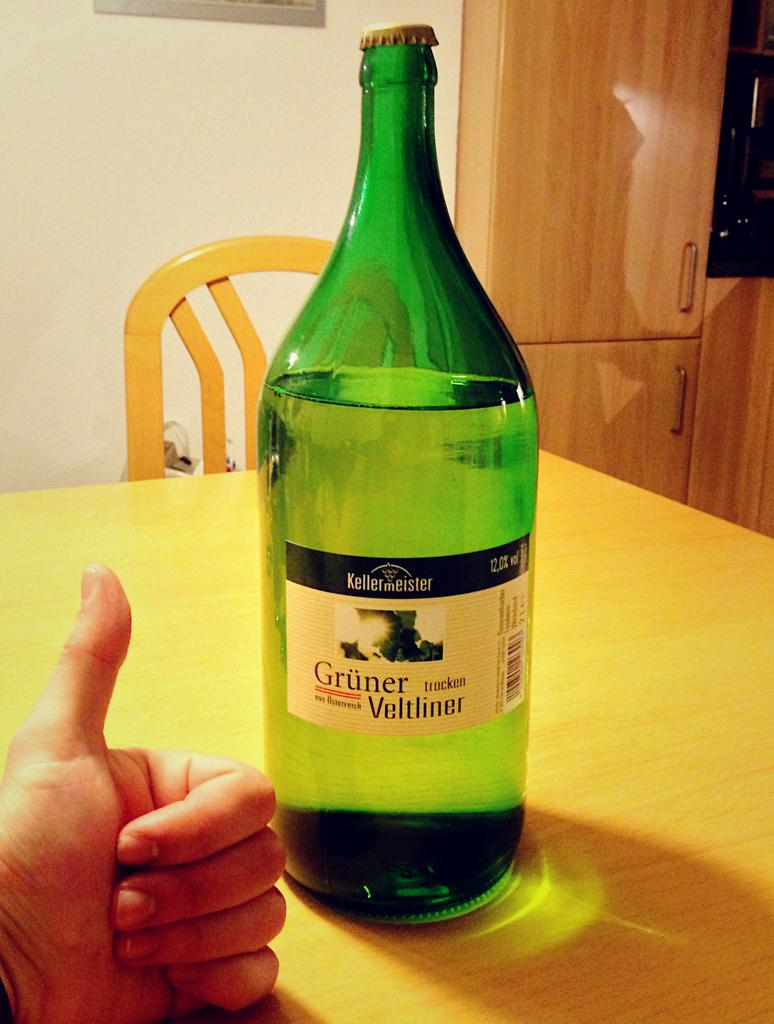<image>
Relay a brief, clear account of the picture shown. A green bottle of Gruner Veltliner is on a table. 